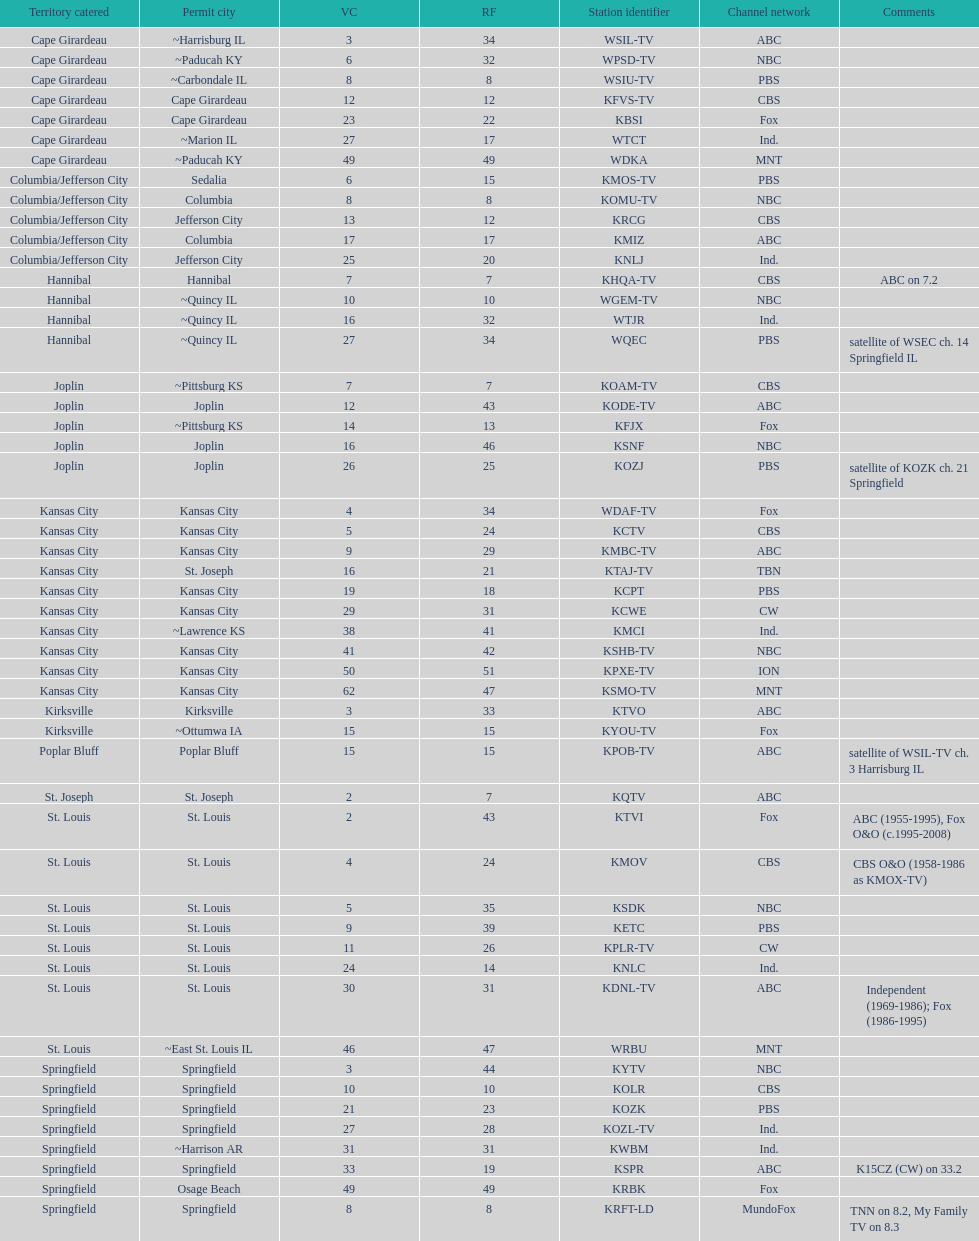What is the total number of stations serving the the cape girardeau area? 7. 